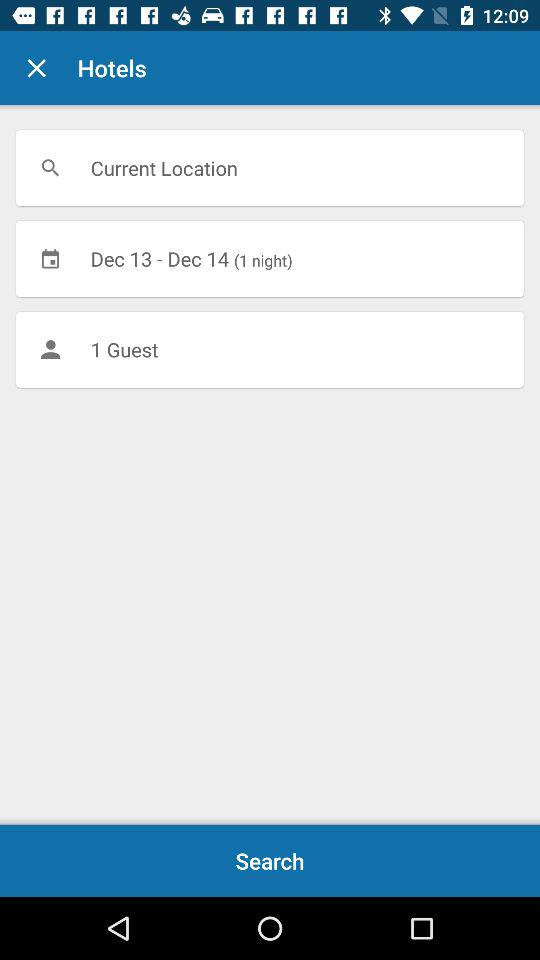What is the selected date range? The selected date range is from December 13 to December 14. 